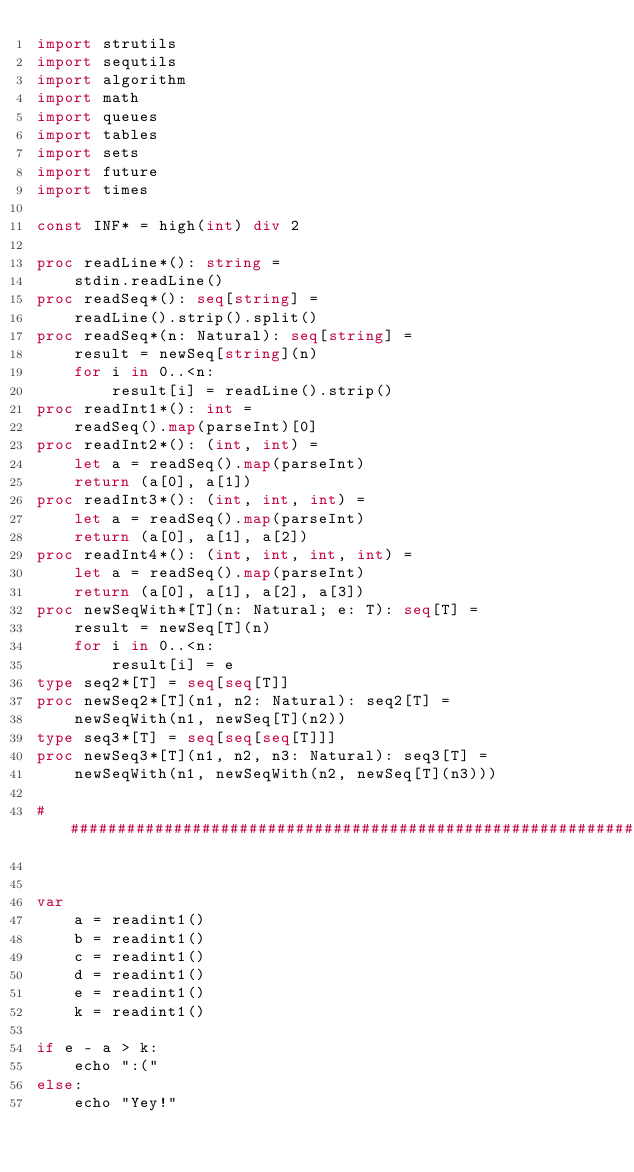Convert code to text. <code><loc_0><loc_0><loc_500><loc_500><_Nim_>import strutils
import sequtils
import algorithm
import math
import queues
import tables
import sets
import future
import times
 
const INF* = high(int) div 2
 
proc readLine*(): string =
    stdin.readLine()
proc readSeq*(): seq[string] =
    readLine().strip().split()
proc readSeq*(n: Natural): seq[string] =
    result = newSeq[string](n)
    for i in 0..<n:
        result[i] = readLine().strip()
proc readInt1*(): int =
    readSeq().map(parseInt)[0]
proc readInt2*(): (int, int) =
    let a = readSeq().map(parseInt)
    return (a[0], a[1])
proc readInt3*(): (int, int, int) =
    let a = readSeq().map(parseInt)
    return (a[0], a[1], a[2])
proc readInt4*(): (int, int, int, int) =
    let a = readSeq().map(parseInt)
    return (a[0], a[1], a[2], a[3])
proc newSeqWith*[T](n: Natural; e: T): seq[T] =
    result = newSeq[T](n)
    for i in 0..<n:
        result[i] = e
type seq2*[T] = seq[seq[T]]
proc newSeq2*[T](n1, n2: Natural): seq2[T] =
    newSeqWith(n1, newSeq[T](n2))
type seq3*[T] = seq[seq[seq[T]]]
proc newSeq3*[T](n1, n2, n3: Natural): seq3[T] =
    newSeqWith(n1, newSeqWith(n2, newSeq[T](n3)))
 
##################################################################


var
    a = readint1()
    b = readint1()
    c = readint1()
    d = readint1()
    e = readint1()
    k = readint1()

if e - a > k:
    echo ":("
else:
    echo "Yey!"</code> 